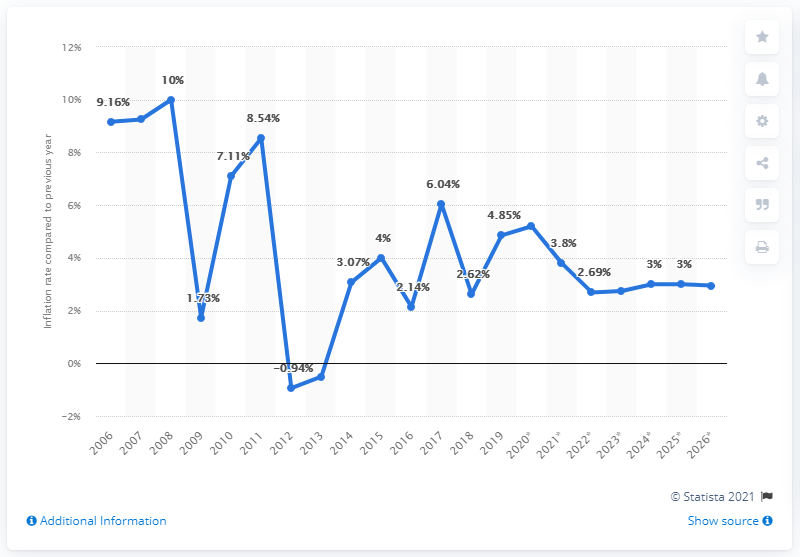Give some essential details in this illustration. In 2015, the inflation rate was 1.86, while in 2016, the inflation rate was 2.13. In 2012, the inflation rate in George went negative, meaning that the general price level of goods and services decreased over time. 